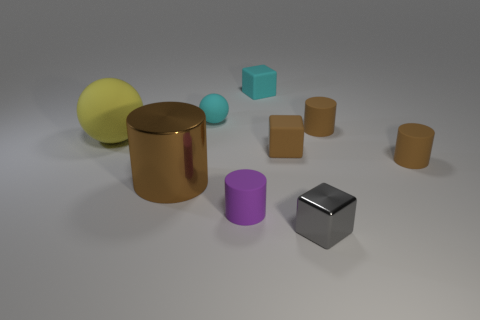Subtract all purple cylinders. How many cylinders are left? 3 Subtract all tiny cylinders. How many cylinders are left? 1 Subtract 3 blocks. How many blocks are left? 0 Add 1 brown blocks. How many objects exist? 10 Subtract all blocks. How many objects are left? 6 Add 9 yellow matte balls. How many yellow matte balls are left? 10 Add 8 metal things. How many metal things exist? 10 Subtract 0 cyan cylinders. How many objects are left? 9 Subtract all gray cylinders. Subtract all blue balls. How many cylinders are left? 4 Subtract all green spheres. How many cyan cubes are left? 1 